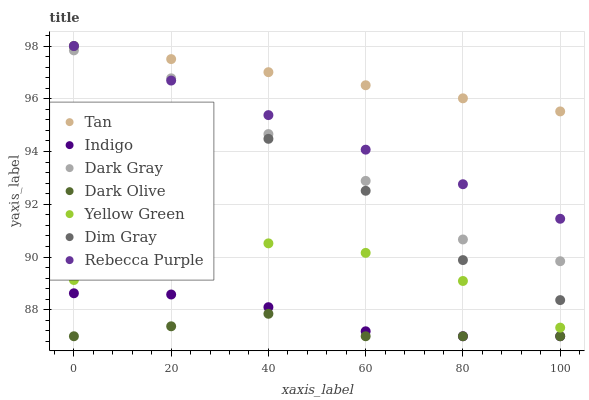Does Dark Olive have the minimum area under the curve?
Answer yes or no. Yes. Does Tan have the maximum area under the curve?
Answer yes or no. Yes. Does Indigo have the minimum area under the curve?
Answer yes or no. No. Does Indigo have the maximum area under the curve?
Answer yes or no. No. Is Rebecca Purple the smoothest?
Answer yes or no. Yes. Is Dim Gray the roughest?
Answer yes or no. Yes. Is Indigo the smoothest?
Answer yes or no. No. Is Indigo the roughest?
Answer yes or no. No. Does Indigo have the lowest value?
Answer yes or no. Yes. Does Yellow Green have the lowest value?
Answer yes or no. No. Does Tan have the highest value?
Answer yes or no. Yes. Does Indigo have the highest value?
Answer yes or no. No. Is Dark Olive less than Tan?
Answer yes or no. Yes. Is Dim Gray greater than Yellow Green?
Answer yes or no. Yes. Does Dark Olive intersect Indigo?
Answer yes or no. Yes. Is Dark Olive less than Indigo?
Answer yes or no. No. Is Dark Olive greater than Indigo?
Answer yes or no. No. Does Dark Olive intersect Tan?
Answer yes or no. No. 